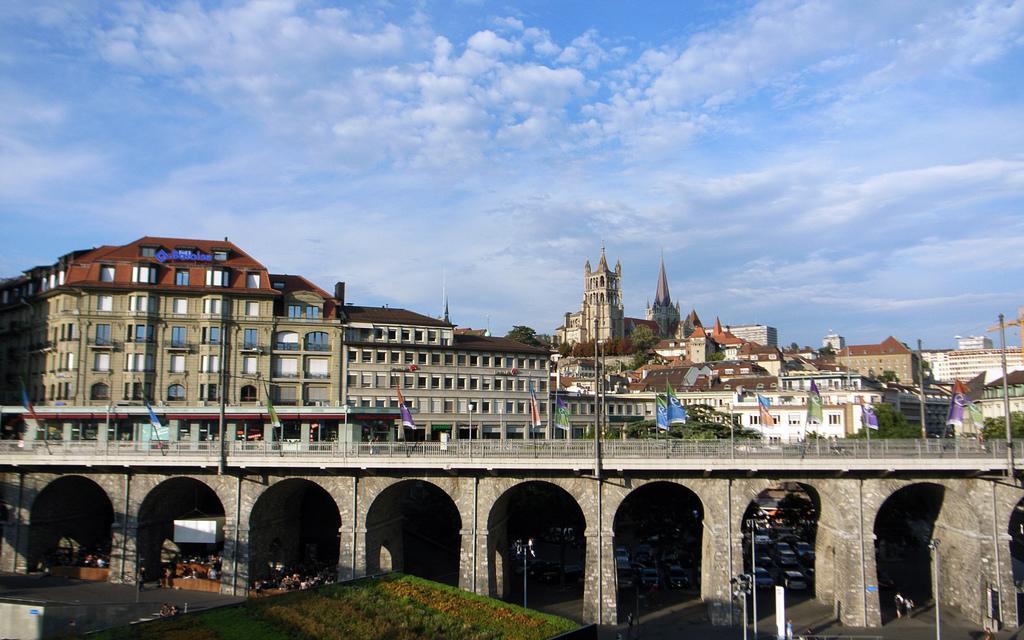Can you describe this image briefly? In this picture we can see a few buildings, flags, poles and arches. There are few traffic signals, vehicles and people on the path. Some greenery is visible. Sky is blue in color and cloudy. 